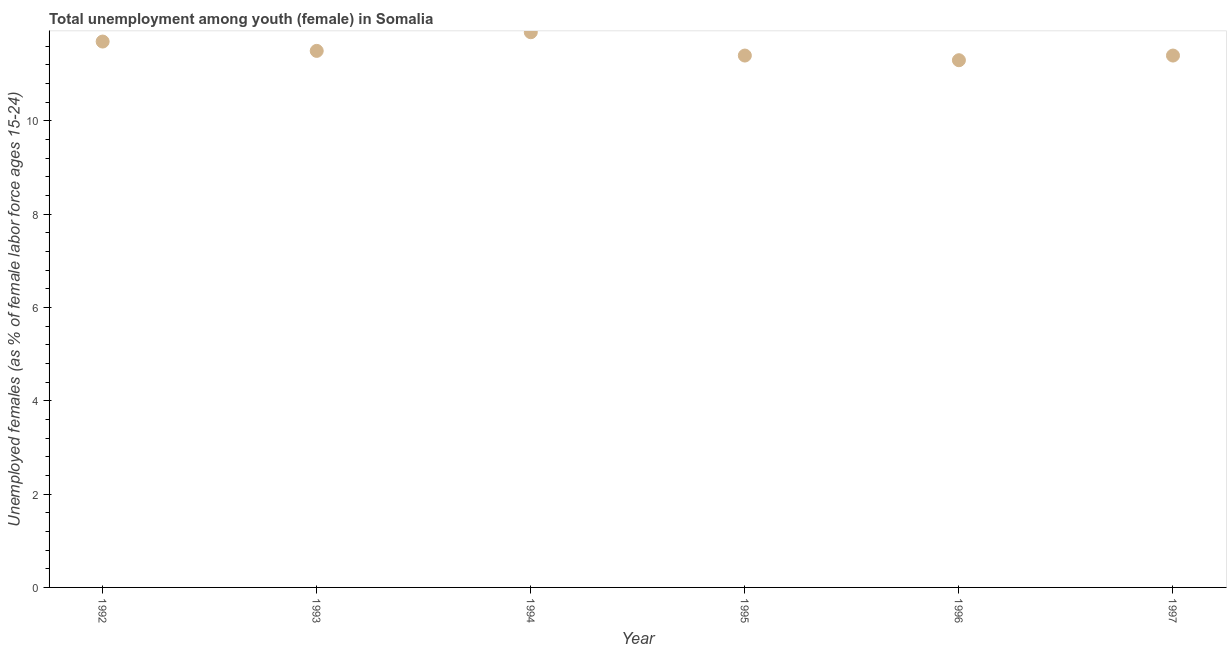What is the unemployed female youth population in 1994?
Your answer should be very brief. 11.9. Across all years, what is the maximum unemployed female youth population?
Your response must be concise. 11.9. Across all years, what is the minimum unemployed female youth population?
Provide a short and direct response. 11.3. What is the sum of the unemployed female youth population?
Provide a short and direct response. 69.2. What is the difference between the unemployed female youth population in 1993 and 1995?
Ensure brevity in your answer.  0.1. What is the average unemployed female youth population per year?
Your answer should be very brief. 11.53. What is the median unemployed female youth population?
Keep it short and to the point. 11.45. Do a majority of the years between 1997 and 1996 (inclusive) have unemployed female youth population greater than 1.6 %?
Provide a short and direct response. No. What is the ratio of the unemployed female youth population in 1994 to that in 1997?
Ensure brevity in your answer.  1.04. Is the difference between the unemployed female youth population in 1993 and 1996 greater than the difference between any two years?
Make the answer very short. No. What is the difference between the highest and the second highest unemployed female youth population?
Give a very brief answer. 0.2. Is the sum of the unemployed female youth population in 1992 and 1993 greater than the maximum unemployed female youth population across all years?
Your answer should be compact. Yes. What is the difference between the highest and the lowest unemployed female youth population?
Your answer should be compact. 0.6. In how many years, is the unemployed female youth population greater than the average unemployed female youth population taken over all years?
Give a very brief answer. 2. Does the unemployed female youth population monotonically increase over the years?
Make the answer very short. No. How many years are there in the graph?
Your answer should be very brief. 6. What is the difference between two consecutive major ticks on the Y-axis?
Your answer should be compact. 2. Are the values on the major ticks of Y-axis written in scientific E-notation?
Your answer should be compact. No. What is the title of the graph?
Your answer should be compact. Total unemployment among youth (female) in Somalia. What is the label or title of the Y-axis?
Offer a very short reply. Unemployed females (as % of female labor force ages 15-24). What is the Unemployed females (as % of female labor force ages 15-24) in 1992?
Ensure brevity in your answer.  11.7. What is the Unemployed females (as % of female labor force ages 15-24) in 1993?
Provide a succinct answer. 11.5. What is the Unemployed females (as % of female labor force ages 15-24) in 1994?
Your response must be concise. 11.9. What is the Unemployed females (as % of female labor force ages 15-24) in 1995?
Your response must be concise. 11.4. What is the Unemployed females (as % of female labor force ages 15-24) in 1996?
Your answer should be very brief. 11.3. What is the Unemployed females (as % of female labor force ages 15-24) in 1997?
Provide a short and direct response. 11.4. What is the difference between the Unemployed females (as % of female labor force ages 15-24) in 1992 and 1994?
Your answer should be very brief. -0.2. What is the difference between the Unemployed females (as % of female labor force ages 15-24) in 1992 and 1995?
Give a very brief answer. 0.3. What is the difference between the Unemployed females (as % of female labor force ages 15-24) in 1993 and 1997?
Your answer should be very brief. 0.1. What is the difference between the Unemployed females (as % of female labor force ages 15-24) in 1994 and 1995?
Offer a very short reply. 0.5. What is the difference between the Unemployed females (as % of female labor force ages 15-24) in 1994 and 1996?
Your response must be concise. 0.6. What is the difference between the Unemployed females (as % of female labor force ages 15-24) in 1995 and 1996?
Give a very brief answer. 0.1. What is the difference between the Unemployed females (as % of female labor force ages 15-24) in 1995 and 1997?
Your answer should be very brief. 0. What is the difference between the Unemployed females (as % of female labor force ages 15-24) in 1996 and 1997?
Provide a short and direct response. -0.1. What is the ratio of the Unemployed females (as % of female labor force ages 15-24) in 1992 to that in 1993?
Offer a terse response. 1.02. What is the ratio of the Unemployed females (as % of female labor force ages 15-24) in 1992 to that in 1994?
Provide a succinct answer. 0.98. What is the ratio of the Unemployed females (as % of female labor force ages 15-24) in 1992 to that in 1995?
Make the answer very short. 1.03. What is the ratio of the Unemployed females (as % of female labor force ages 15-24) in 1992 to that in 1996?
Your answer should be very brief. 1.03. What is the ratio of the Unemployed females (as % of female labor force ages 15-24) in 1993 to that in 1996?
Make the answer very short. 1.02. What is the ratio of the Unemployed females (as % of female labor force ages 15-24) in 1993 to that in 1997?
Ensure brevity in your answer.  1.01. What is the ratio of the Unemployed females (as % of female labor force ages 15-24) in 1994 to that in 1995?
Provide a succinct answer. 1.04. What is the ratio of the Unemployed females (as % of female labor force ages 15-24) in 1994 to that in 1996?
Provide a short and direct response. 1.05. What is the ratio of the Unemployed females (as % of female labor force ages 15-24) in 1994 to that in 1997?
Your response must be concise. 1.04. What is the ratio of the Unemployed females (as % of female labor force ages 15-24) in 1996 to that in 1997?
Provide a succinct answer. 0.99. 